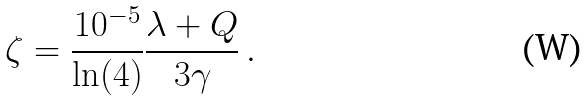<formula> <loc_0><loc_0><loc_500><loc_500>\zeta = \frac { 1 0 ^ { - 5 } } { \ln ( 4 ) } \frac { \lambda + Q } { 3 \gamma } \, .</formula> 